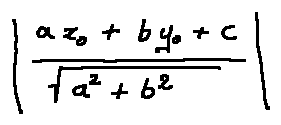<formula> <loc_0><loc_0><loc_500><loc_500>| \frac { a x _ { 0 } + b y _ { 0 } + c } { \sqrt { a ^ { 2 } + b ^ { 2 } } } |</formula> 